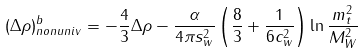<formula> <loc_0><loc_0><loc_500><loc_500>\left ( \Delta \rho \right ) _ { n o n u n i v } ^ { b } = - \frac { 4 } { 3 } \Delta \rho - \frac { \alpha } { 4 \pi s _ { w } ^ { 2 } } \left ( \frac { 8 } { 3 } + \frac { 1 } { 6 c _ { w } ^ { 2 } } \right ) \ln \frac { m _ { t } ^ { 2 } } { M _ { W } ^ { 2 } }</formula> 